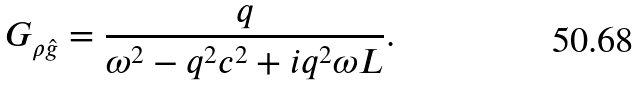Convert formula to latex. <formula><loc_0><loc_0><loc_500><loc_500>G _ { \rho \hat { g } } = \frac { q } { \omega ^ { 2 } - q ^ { 2 } c ^ { 2 } + i q ^ { 2 } \omega L } .</formula> 